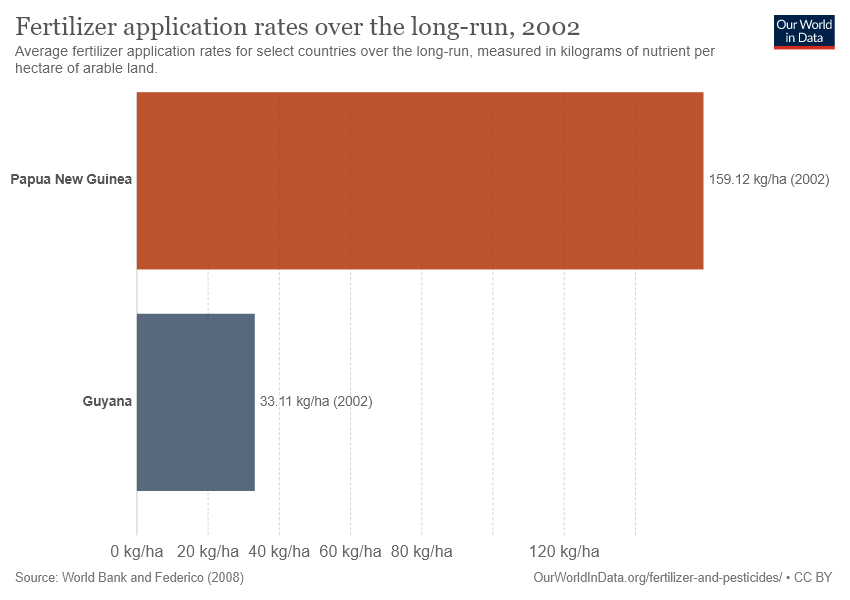List a handful of essential elements in this visual. There are two categories in the chart. The rate in Guyana is not twice that of Papua New Guinea. 